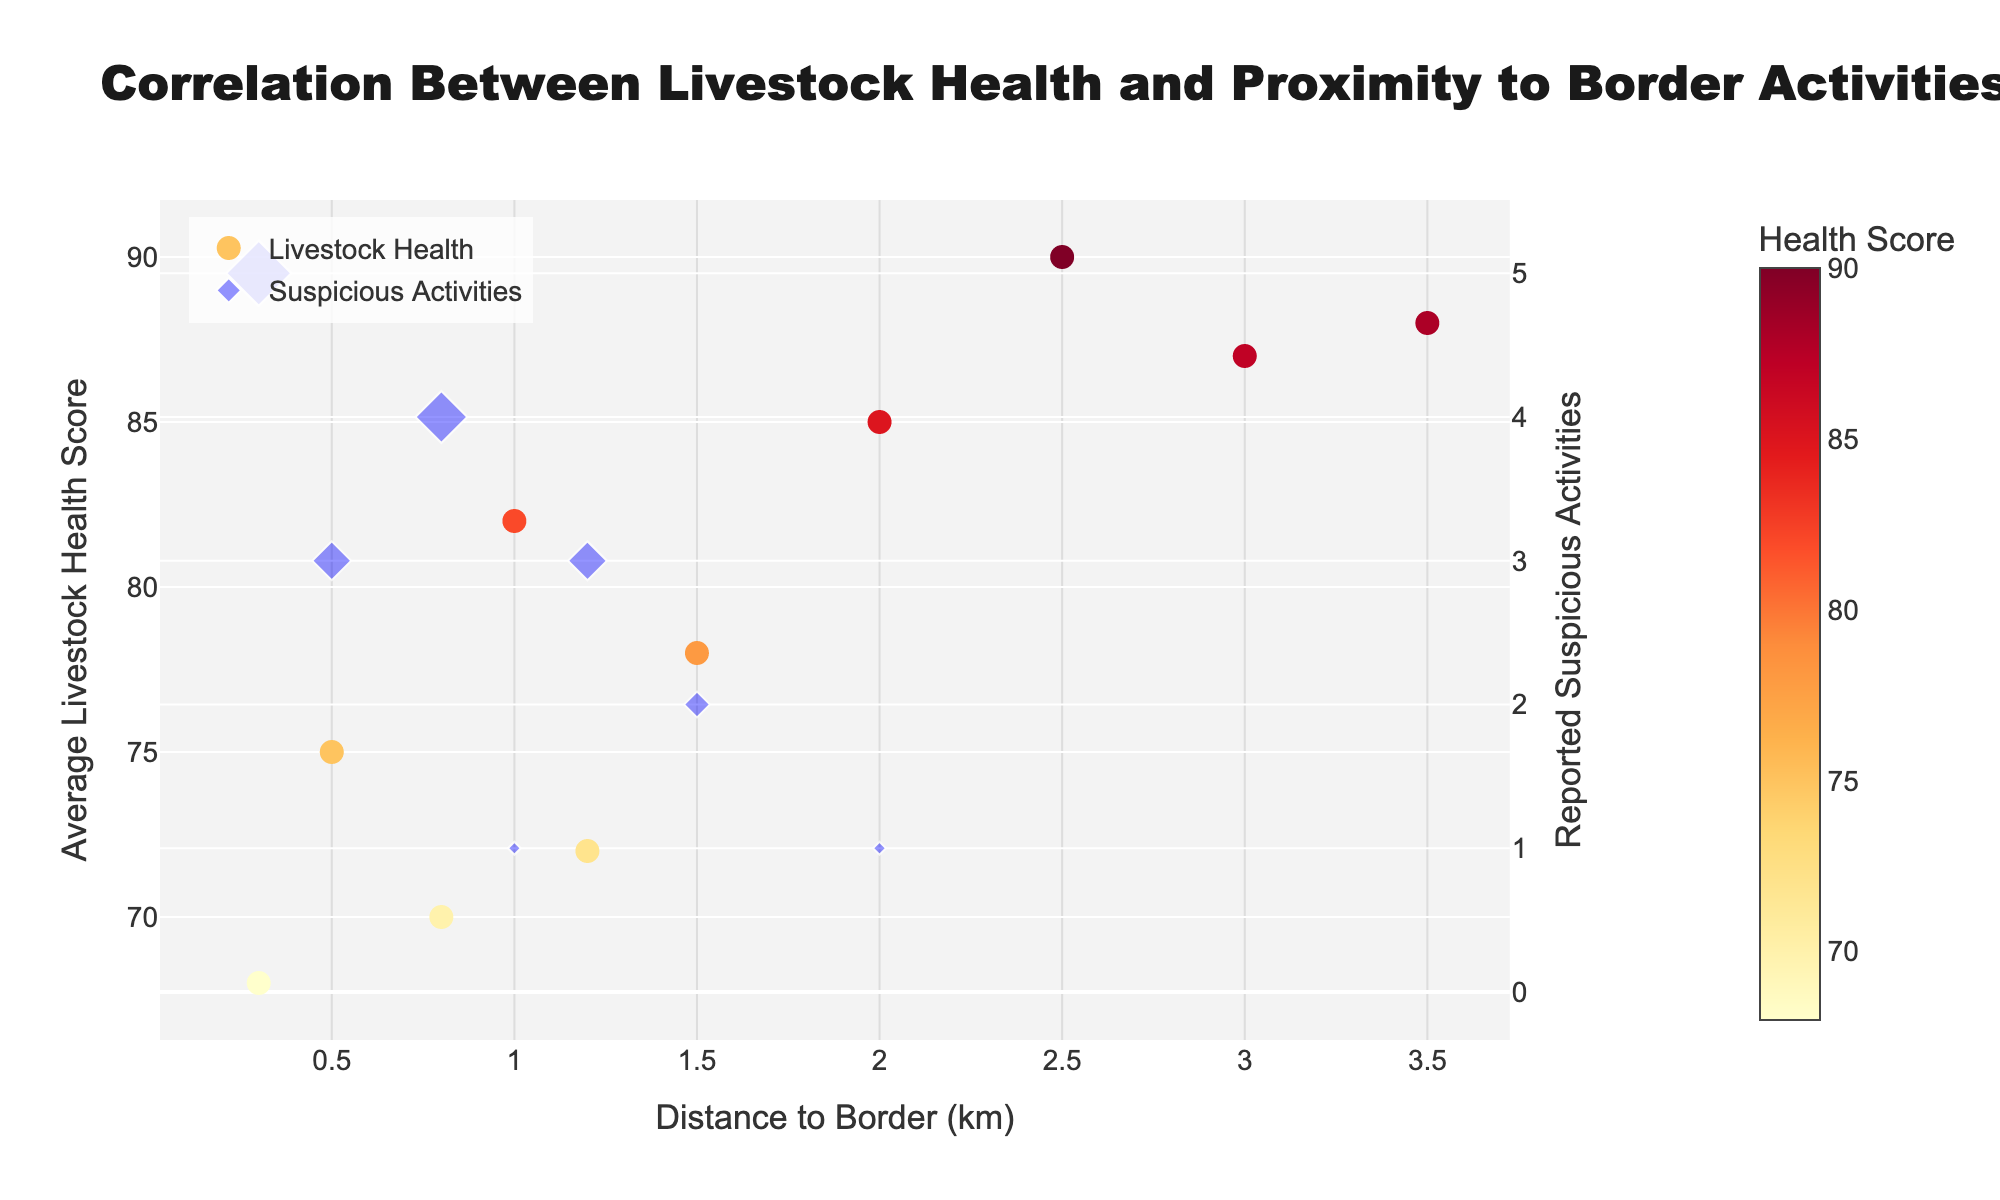What is the title of the plot? The title of the plot is located at the top, and it indicates what the plot is about.
Answer: Correlation Between Livestock Health and Proximity to Border Activities How many distinct distances to the border are represented in the plot? Count the unique values on the x-axis representing the distance to the border. The plot shows ten distinct distances.
Answer: 10 What is the general trend of livestock health scores relative to the distance from the border? Observe the scattered points representing livestock health scores across the x-axis (distance to the border). The health scores generally increase as the distance from the border increases.
Answer: Livestock health scores increase with distance from the border At what distance to the border was the highest livestock health score recorded? Identify the point with the highest y-value (health score) and read the corresponding x-axis value (distance to the border). The highest score is 90 at a distance of 2.5 km from the border.
Answer: 2.5 km Which distance to the border has the highest number of reported suspicious activities and what is that number? Identify the markers for suspicious activities and find the one with the largest size. The highest number of suspicious activities is 5 at a distance of 0.3 km from the border.
Answer: 0.3 km, 5 What is the average livestock health score for distances less than 1 km from the border? Sum the livestock health scores for distances less than 1 km (75, 70, 72, 68) and divide by the number of these scores (4). (75+70+72+68)/4 = 285/4 = 71.25
Answer: 71.25 Which distance to the border shows equal reported suspicious activities and livestock health score? Identify any points where the reported suspicious activities value matches the livestock health score value. None of the points have equal values for both metrics.
Answer: None Is there any distance where no suspicious activities were reported and what are the corresponding livestock health scores? Check the points where the suspicious activities value is zero and note the corresponding livestock health score. Distances with zero reports are 2.5 km, 3.0 km, and 3.5 km with scores 90, 87, and 88 respectively.
Answer: 90, 87, 88 What is the difference in the average livestock health scores between distances less than 1.5 km and those greater than 1.5 km? Calculate average scores for both sets: (75+82+70+72+68)/5 = 367/5 = 73.4 for <1.5 km, (90+87+85+88)/4 = 350/4 = 87.5 for >1.5 km. Difference is 87.5 - 73.4 = 14.1.
Answer: 14.1 